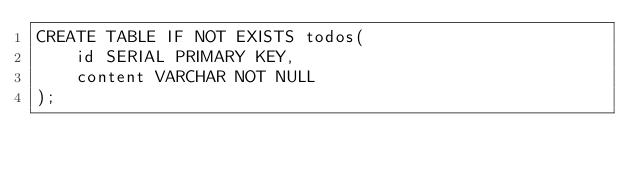<code> <loc_0><loc_0><loc_500><loc_500><_SQL_>CREATE TABLE IF NOT EXISTS todos(
    id SERIAL PRIMARY KEY, 
    content VARCHAR NOT NULL
);
</code> 